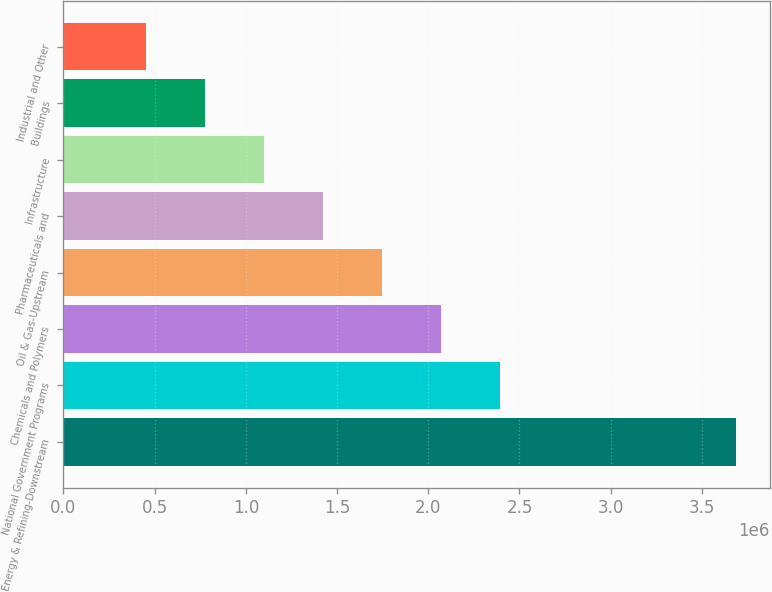Convert chart to OTSL. <chart><loc_0><loc_0><loc_500><loc_500><bar_chart><fcel>Energy & Refining-Downstream<fcel>National Government Programs<fcel>Chemicals and Polymers<fcel>Oil & Gas-Upstream<fcel>Pharmaceuticals and<fcel>Infrastructure<fcel>Buildings<fcel>Industrial and Other<nl><fcel>3.6878e+06<fcel>2.39399e+06<fcel>2.07054e+06<fcel>1.74709e+06<fcel>1.42364e+06<fcel>1.10019e+06<fcel>776736<fcel>453285<nl></chart> 